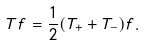Convert formula to latex. <formula><loc_0><loc_0><loc_500><loc_500>T f = \frac { 1 } { 2 } ( T _ { + } + T _ { - } ) f .</formula> 